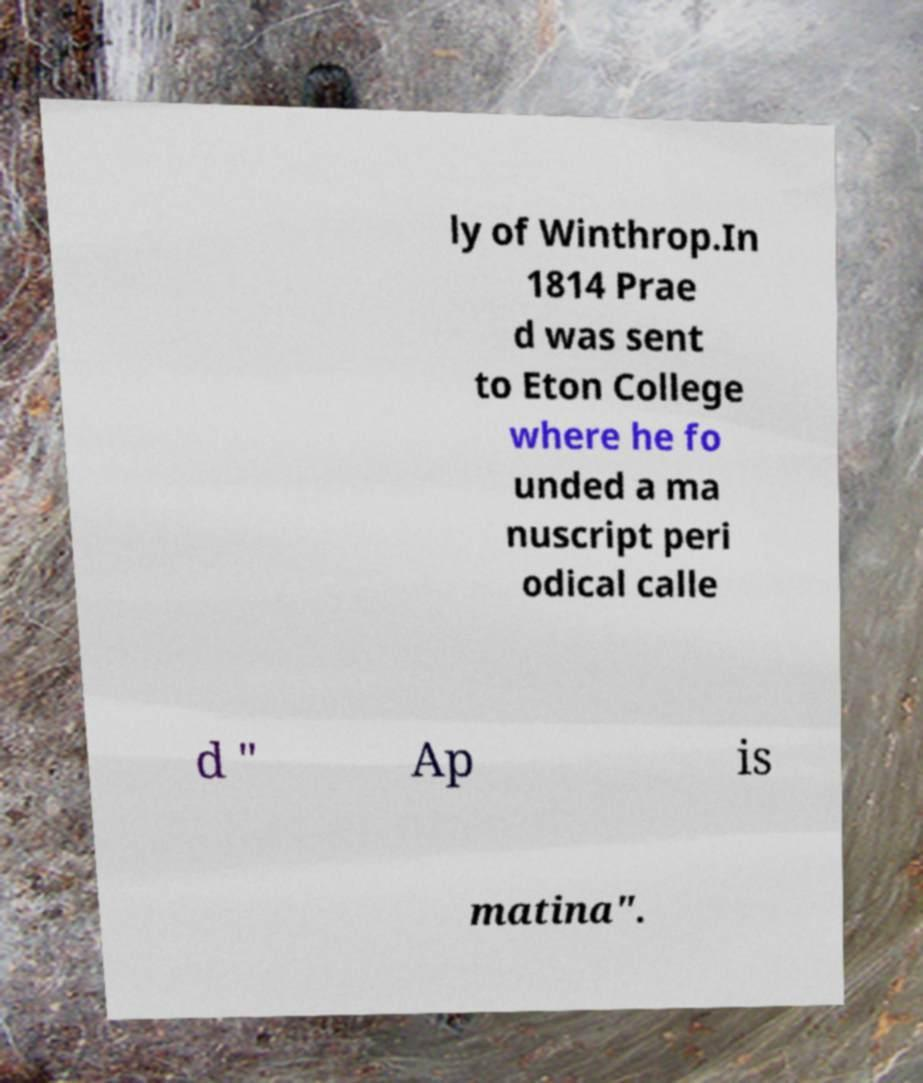Could you extract and type out the text from this image? ly of Winthrop.In 1814 Prae d was sent to Eton College where he fo unded a ma nuscript peri odical calle d " Ap is matina". 